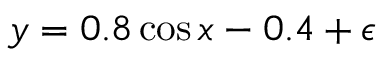Convert formula to latex. <formula><loc_0><loc_0><loc_500><loc_500>y = 0 . 8 \cos x - 0 . 4 + \epsilon</formula> 